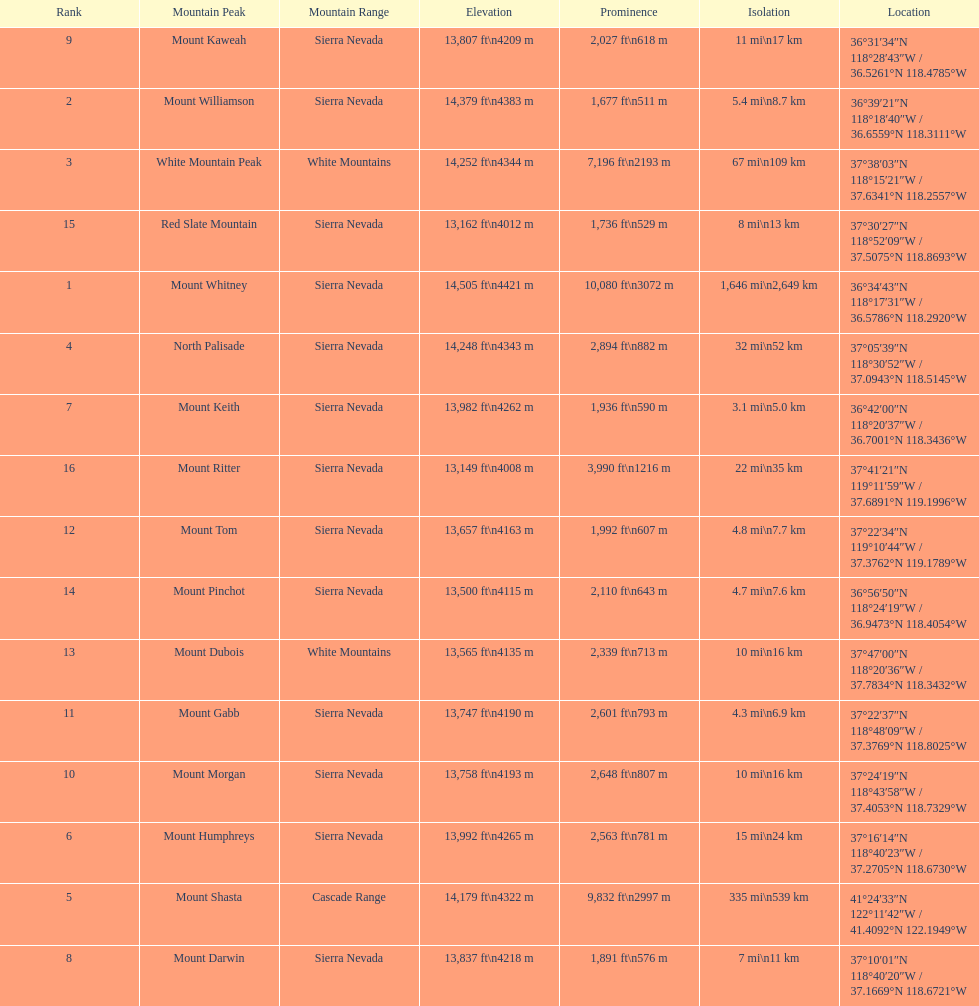What are all of the peaks? Mount Whitney, Mount Williamson, White Mountain Peak, North Palisade, Mount Shasta, Mount Humphreys, Mount Keith, Mount Darwin, Mount Kaweah, Mount Morgan, Mount Gabb, Mount Tom, Mount Dubois, Mount Pinchot, Red Slate Mountain, Mount Ritter. Where are they located? Sierra Nevada, Sierra Nevada, White Mountains, Sierra Nevada, Cascade Range, Sierra Nevada, Sierra Nevada, Sierra Nevada, Sierra Nevada, Sierra Nevada, Sierra Nevada, Sierra Nevada, White Mountains, Sierra Nevada, Sierra Nevada, Sierra Nevada. How tall are they? 14,505 ft\n4421 m, 14,379 ft\n4383 m, 14,252 ft\n4344 m, 14,248 ft\n4343 m, 14,179 ft\n4322 m, 13,992 ft\n4265 m, 13,982 ft\n4262 m, 13,837 ft\n4218 m, 13,807 ft\n4209 m, 13,758 ft\n4193 m, 13,747 ft\n4190 m, 13,657 ft\n4163 m, 13,565 ft\n4135 m, 13,500 ft\n4115 m, 13,162 ft\n4012 m, 13,149 ft\n4008 m. What about just the peaks in the sierra nevadas? 14,505 ft\n4421 m, 14,379 ft\n4383 m, 14,248 ft\n4343 m, 13,992 ft\n4265 m, 13,982 ft\n4262 m, 13,837 ft\n4218 m, 13,807 ft\n4209 m, 13,758 ft\n4193 m, 13,747 ft\n4190 m, 13,657 ft\n4163 m, 13,500 ft\n4115 m, 13,162 ft\n4012 m, 13,149 ft\n4008 m. And of those, which is the tallest? Mount Whitney. 